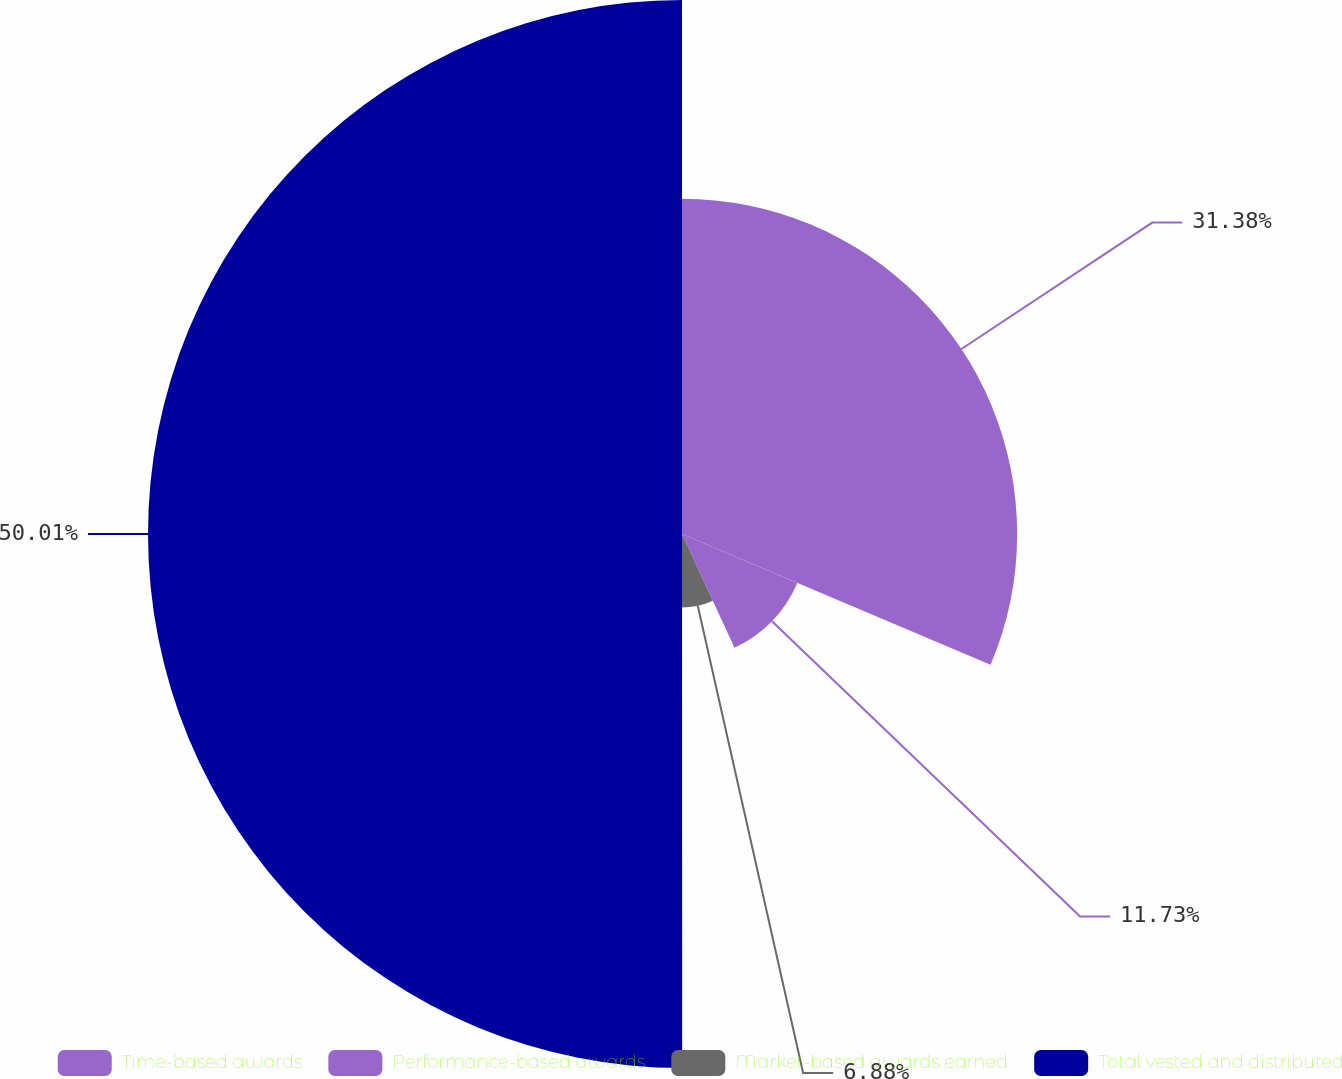Convert chart to OTSL. <chart><loc_0><loc_0><loc_500><loc_500><pie_chart><fcel>Time-based awards<fcel>Performance-based awards<fcel>Market-based awards earned<fcel>Total vested and distributed<nl><fcel>31.38%<fcel>11.73%<fcel>6.88%<fcel>50.0%<nl></chart> 